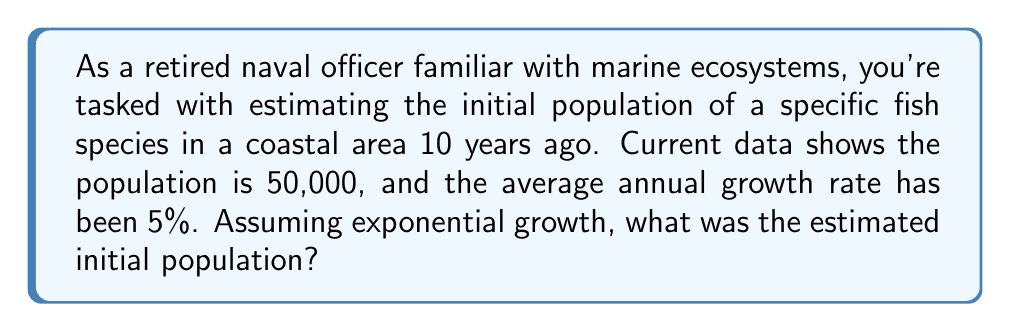Show me your answer to this math problem. To solve this inverse problem, we'll use the exponential growth formula and work backwards:

1) The exponential growth formula is:
   $$P(t) = P_0 e^{rt}$$
   Where:
   $P(t)$ is the population at time $t$
   $P_0$ is the initial population
   $r$ is the growth rate
   $t$ is the time period

2) We know:
   $P(10) = 50,000$ (current population after 10 years)
   $r = 0.05$ (5% annual growth rate)
   $t = 10$ years

3) Substituting these values:
   $$50,000 = P_0 e^{0.05 \cdot 10}$$

4) Simplify the exponent:
   $$50,000 = P_0 e^{0.5}$$

5) Divide both sides by $e^{0.5}$:
   $$\frac{50,000}{e^{0.5}} = P_0$$

6) Calculate:
   $$P_0 = \frac{50,000}{e^{0.5}} \approx 30,326.53$$

7) Round to the nearest whole number:
   $$P_0 \approx 30,327$$
Answer: 30,327 fish 